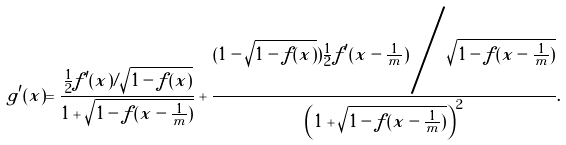Convert formula to latex. <formula><loc_0><loc_0><loc_500><loc_500>g ^ { \prime } ( x ) = \frac { \frac { 1 } { 2 } f ^ { \prime } ( x ) / \sqrt { 1 - f ( x ) } } { 1 + \sqrt { 1 - f ( x - \frac { 1 } { m } ) } } + \frac { ( 1 - \sqrt { 1 - f ( x ) } ) \frac { 1 } { 2 } f ^ { \prime } ( x - \frac { 1 } { m } ) \Big / \sqrt { 1 - f ( x - \frac { 1 } { m } ) } } { \left ( 1 + \sqrt { 1 - f ( x - \frac { 1 } { m } ) } \right ) ^ { 2 } } .</formula> 